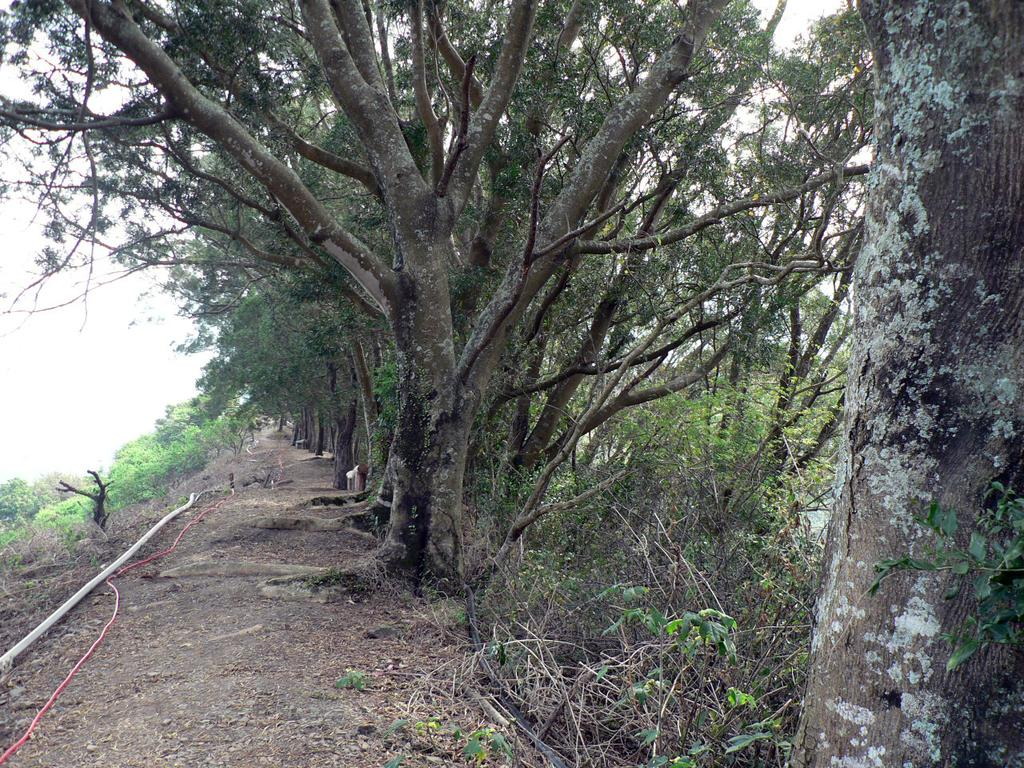What is the primary feature of the image? There are many trees in the image. What can be seen in the background of the image? The sky is visible in the background of the image. What type of cakes are being served at the event in the image? There is no event or cakes present in the image; it features trees and the sky. 